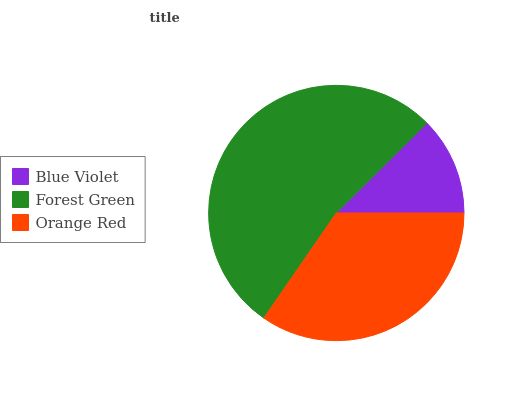Is Blue Violet the minimum?
Answer yes or no. Yes. Is Forest Green the maximum?
Answer yes or no. Yes. Is Orange Red the minimum?
Answer yes or no. No. Is Orange Red the maximum?
Answer yes or no. No. Is Forest Green greater than Orange Red?
Answer yes or no. Yes. Is Orange Red less than Forest Green?
Answer yes or no. Yes. Is Orange Red greater than Forest Green?
Answer yes or no. No. Is Forest Green less than Orange Red?
Answer yes or no. No. Is Orange Red the high median?
Answer yes or no. Yes. Is Orange Red the low median?
Answer yes or no. Yes. Is Forest Green the high median?
Answer yes or no. No. Is Forest Green the low median?
Answer yes or no. No. 